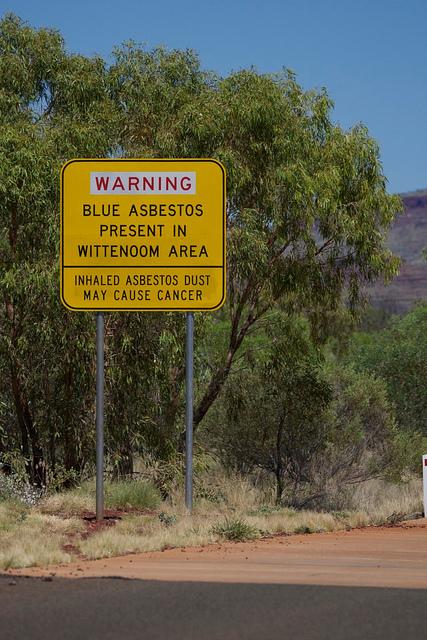Are there clouds in the sky?
Keep it brief. No. Is the sign far from the road?
Answer briefly. No. What type of asbestos  is present in the area?
Short answer required. Blue. What does the sign say?
Give a very brief answer. Warning. What is the name of the street?
Give a very brief answer. Wittenoom. Do you see train tracks?
Write a very short answer. No. What color is the grass?
Short answer required. Green. How many signs are posted?
Keep it brief. 1. What street is the stop sign at?
Write a very short answer. Wittenoom. 